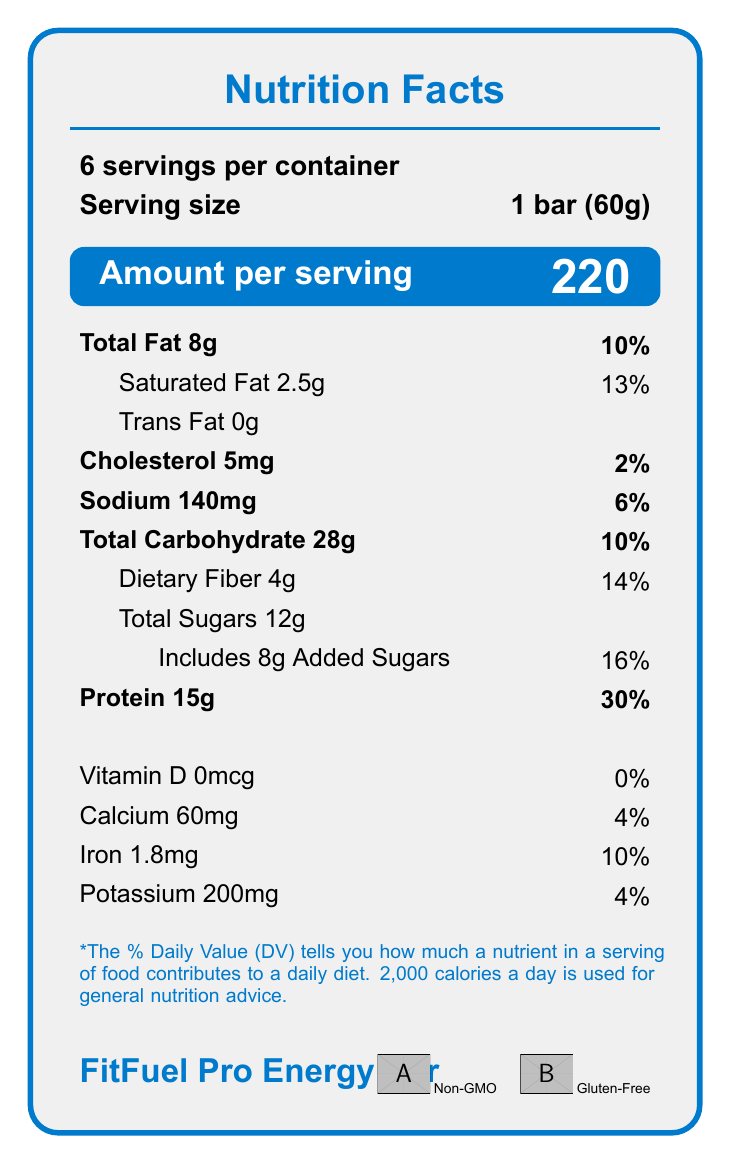what is the serving size? The document specifies the serving size as "1 bar (60g)" in the serving information section.
Answer: 1 bar (60g) how many calories are in one serving? The calorie information section clearly states that each bar contains 220 calories.
Answer: 220 how much total fat does one bar contain? In the nutrient table, total fat is listed as "Total Fat 8g."
Answer: 8g how much protein is in one serving? According to the nutrient table, one bar contains "Protein 15g."
Answer: 15g how many bars are in one container? The document specifies this in the serving information section: "6 servings per container."
Answer: 6 what is the percentage of daily value for saturated fat? The nutrient table lists "Saturated Fat 2.5g" with a daily value of "13%."
Answer: 13% how much iron is in each bar? A. 1.0mg B. 1.8mg C. 2.0mg D. 2.5mg The nutrient table shows that each bar contains "Iron 1.8mg."
Answer: B what is the percentage daily value for sodium? A. 2% B. 4% C. 6% D. 8% The document states that sodium has a daily value of "6%."
Answer: C does this product contain any trans fat? The nutrient table states "Trans Fat 0g," indicating there is no trans fat in the product.
Answer: No are there any allergens in this product? The allergen section lists: "Contains milk and tree nuts (almonds). May contain traces of soy and peanuts."
Answer: Yes is this product certified gluten-free? The certifications section confirms that the product is "Gluten-Free."
Answer: Yes what is the main idea of the document? The document is a detailed listing of the nutrition facts, ingredients, storage instructions, allergen information, and certifications relating to the FitFuel Pro Energy Bar, targeted at consumers who are focused on fitness and dietary health.
Answer: The document provides nutrition facts and other essential information about the FitFuel Pro Energy Bar, including its ingredients, allergen warnings, and nutritional content per serving. how much vitamin d is in each bar? The nutrient table lists "Vitamin D 0mcg," indicating there is no vitamin D in the product.
Answer: 0mcg what is the company that manufactures this product? The document states the manufacturer as "NutriTech Fitness Foods, Inc."
Answer: NutriTech Fitness Foods, Inc. can this product be considered a good source of dietary fiber? The nutrient table reveals that the product contains "Dietary Fiber 4g," which is 14% of the daily value, making it a good source of dietary fiber.
Answer: Yes what percentage of the packaging is made from post-consumer recycled materials? The sustainability information section notes that "Packaging made from 30% post-consumer recycled materials."
Answer: 30% how many grams of added sugars are in one serving? The nutrient table specifies that the bar contains "Includes 8g Added Sugars."
Answer: 8g does the document state the exact ingredients used in the product? The ingredients list includes detailed components such as "Whey protein isolate, Brown rice syrup, Almonds," etc.
Answer: Yes what is the website for more information about the product? The document provides the website as "www.fitfuelpro.com."
Answer: www.fitfuelpro.com does the product contain any animal derivatives? The ingredients list includes "Whey protein isolate," which is derived from milk.
Answer: Yes can the exact manufacturing process of the energy bar be determined from the document? The document details ingredients and nutritional information but does not include specific manufacturing processes.
Answer: Not enough information 